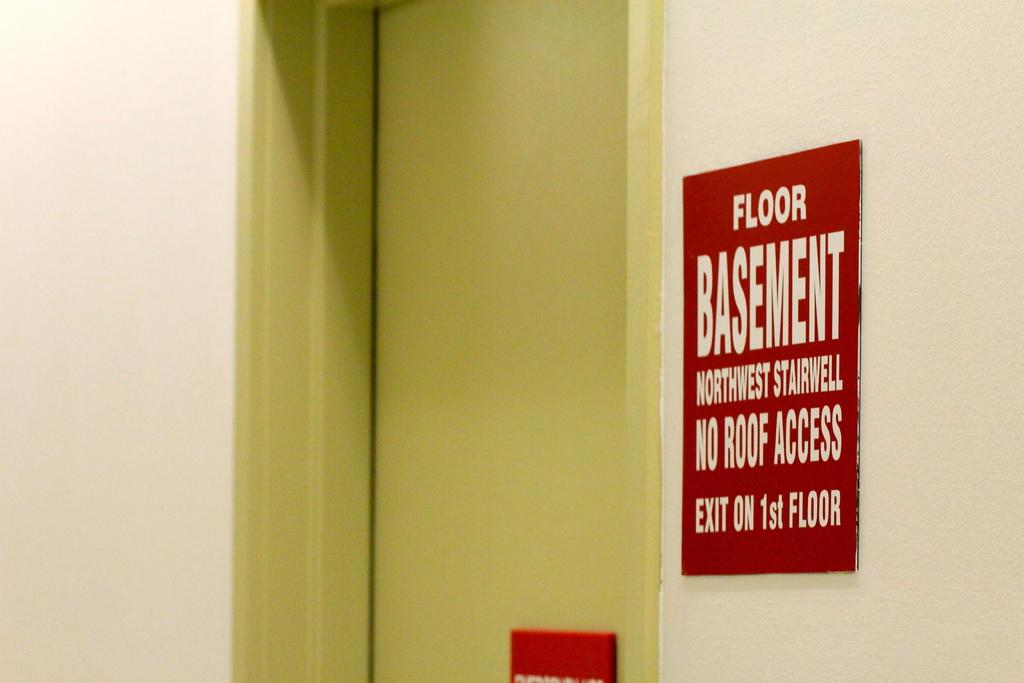<image>
Share a concise interpretation of the image provided. Red sign next to a door with Floor Basement Northwest Stairwell No Roof Access Exit on 1st Floor in white letters 